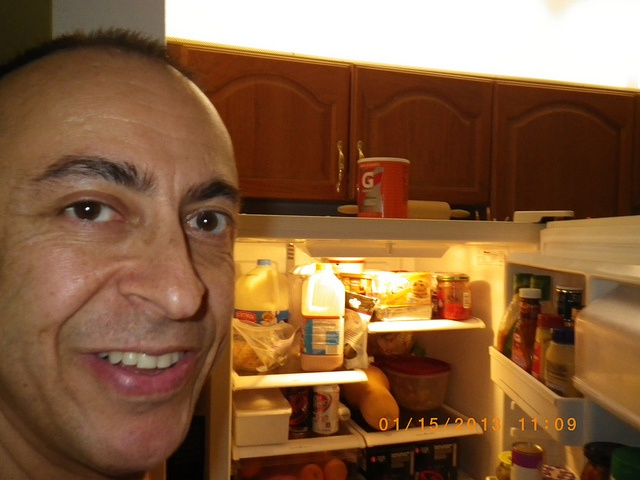Describe the objects in this image and their specific colors. I can see refrigerator in black, brown, maroon, and orange tones, people in black, gray, brown, and maroon tones, bottle in black, ivory, red, khaki, and gold tones, bowl in black, maroon, and brown tones, and bottle in black, maroon, and brown tones in this image. 